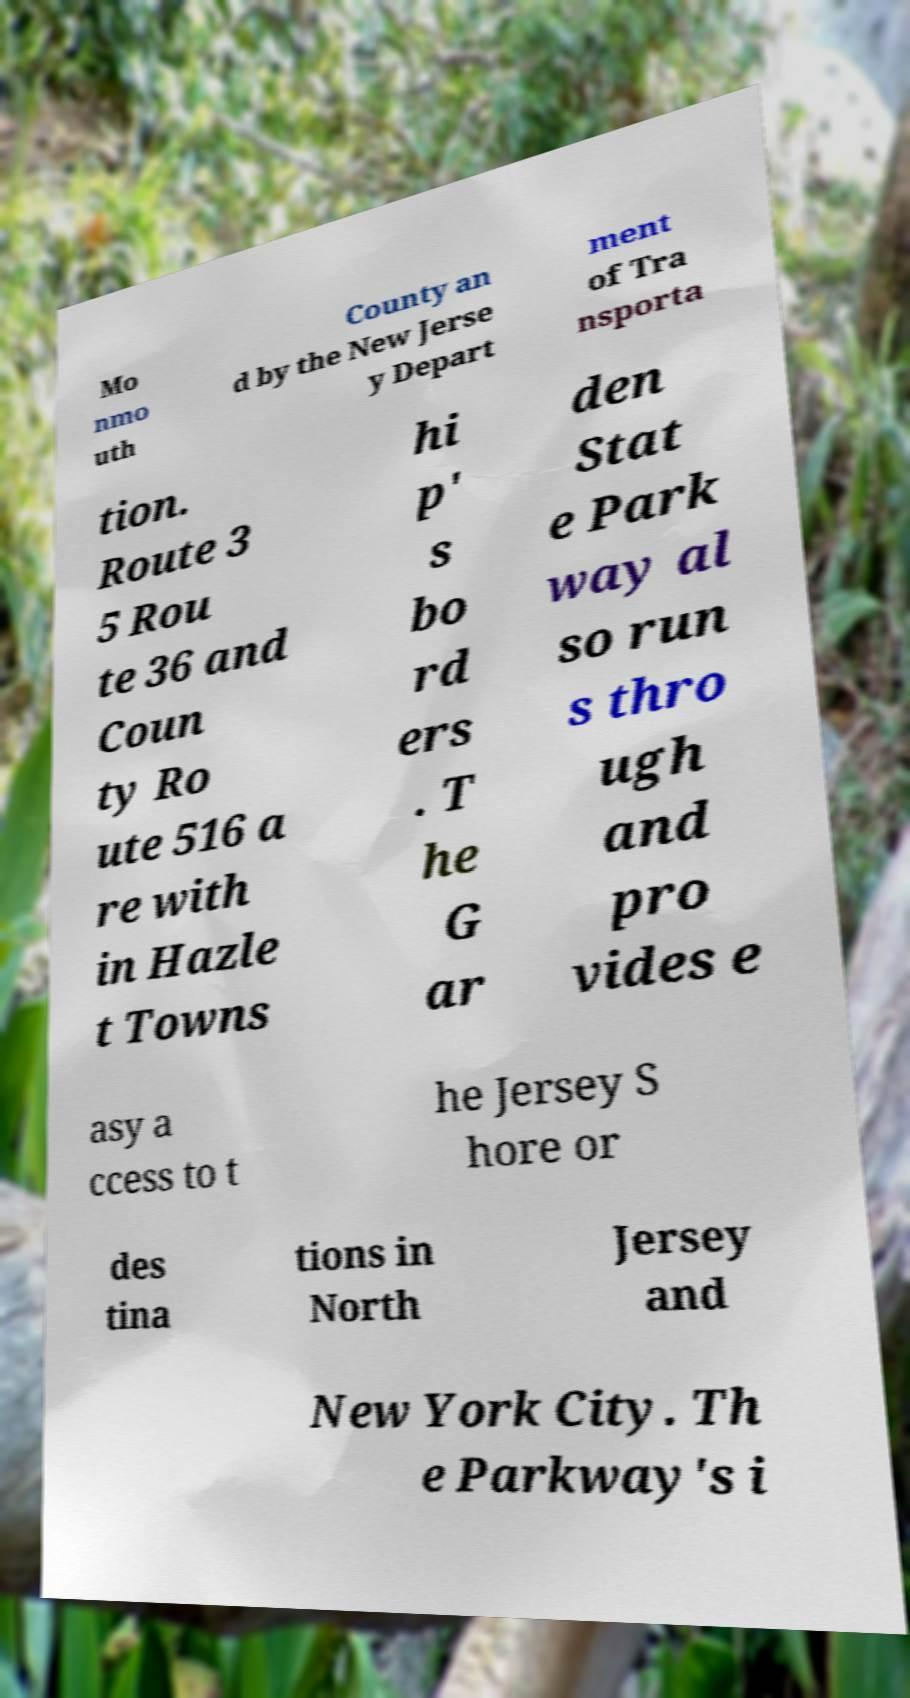Please identify and transcribe the text found in this image. Mo nmo uth County an d by the New Jerse y Depart ment of Tra nsporta tion. Route 3 5 Rou te 36 and Coun ty Ro ute 516 a re with in Hazle t Towns hi p' s bo rd ers . T he G ar den Stat e Park way al so run s thro ugh and pro vides e asy a ccess to t he Jersey S hore or des tina tions in North Jersey and New York City. Th e Parkway's i 